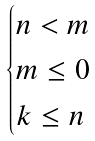Convert formula to latex. <formula><loc_0><loc_0><loc_500><loc_500>\begin{cases} n < m \\ m \leq 0 \\ k \leq n \end{cases}</formula> 